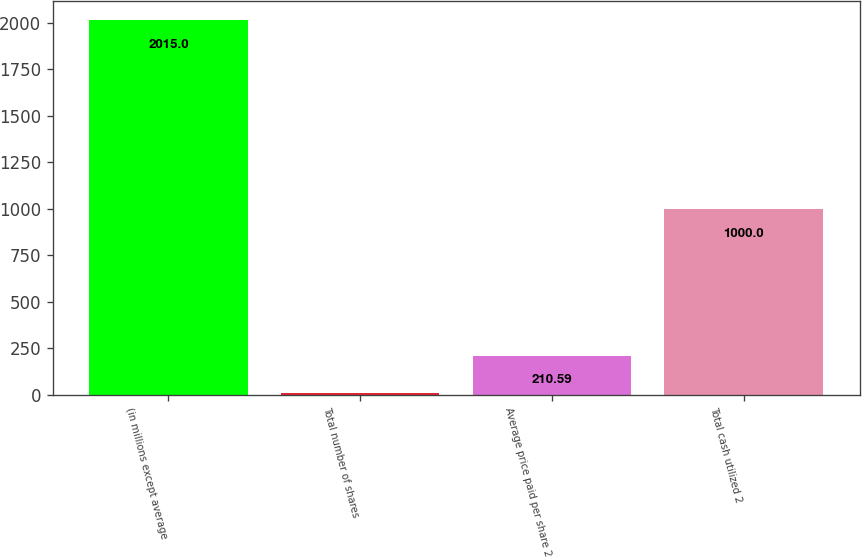Convert chart to OTSL. <chart><loc_0><loc_0><loc_500><loc_500><bar_chart><fcel>(in millions except average<fcel>Total number of shares<fcel>Average price paid per share 2<fcel>Total cash utilized 2<nl><fcel>2015<fcel>10.1<fcel>210.59<fcel>1000<nl></chart> 